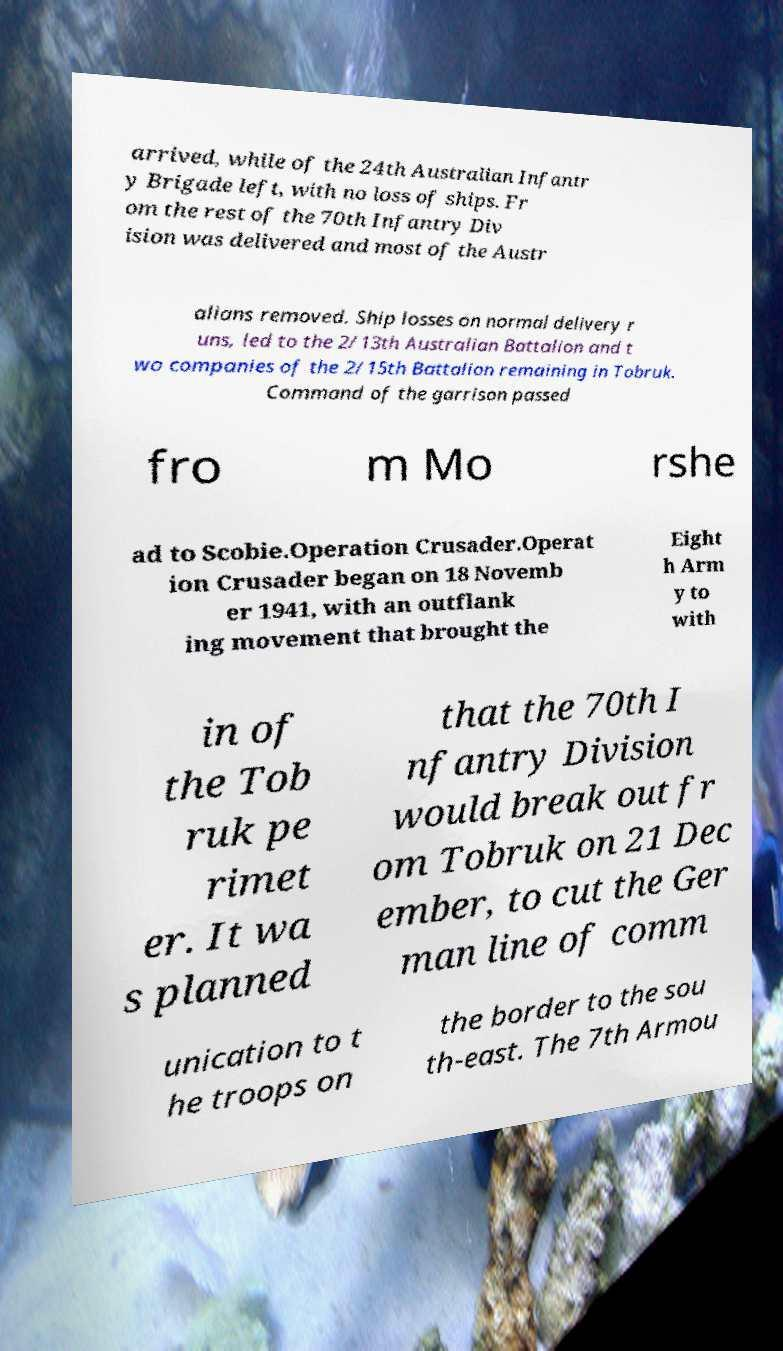Please identify and transcribe the text found in this image. arrived, while of the 24th Australian Infantr y Brigade left, with no loss of ships. Fr om the rest of the 70th Infantry Div ision was delivered and most of the Austr alians removed. Ship losses on normal delivery r uns, led to the 2/13th Australian Battalion and t wo companies of the 2/15th Battalion remaining in Tobruk. Command of the garrison passed fro m Mo rshe ad to Scobie.Operation Crusader.Operat ion Crusader began on 18 Novemb er 1941, with an outflank ing movement that brought the Eight h Arm y to with in of the Tob ruk pe rimet er. It wa s planned that the 70th I nfantry Division would break out fr om Tobruk on 21 Dec ember, to cut the Ger man line of comm unication to t he troops on the border to the sou th-east. The 7th Armou 